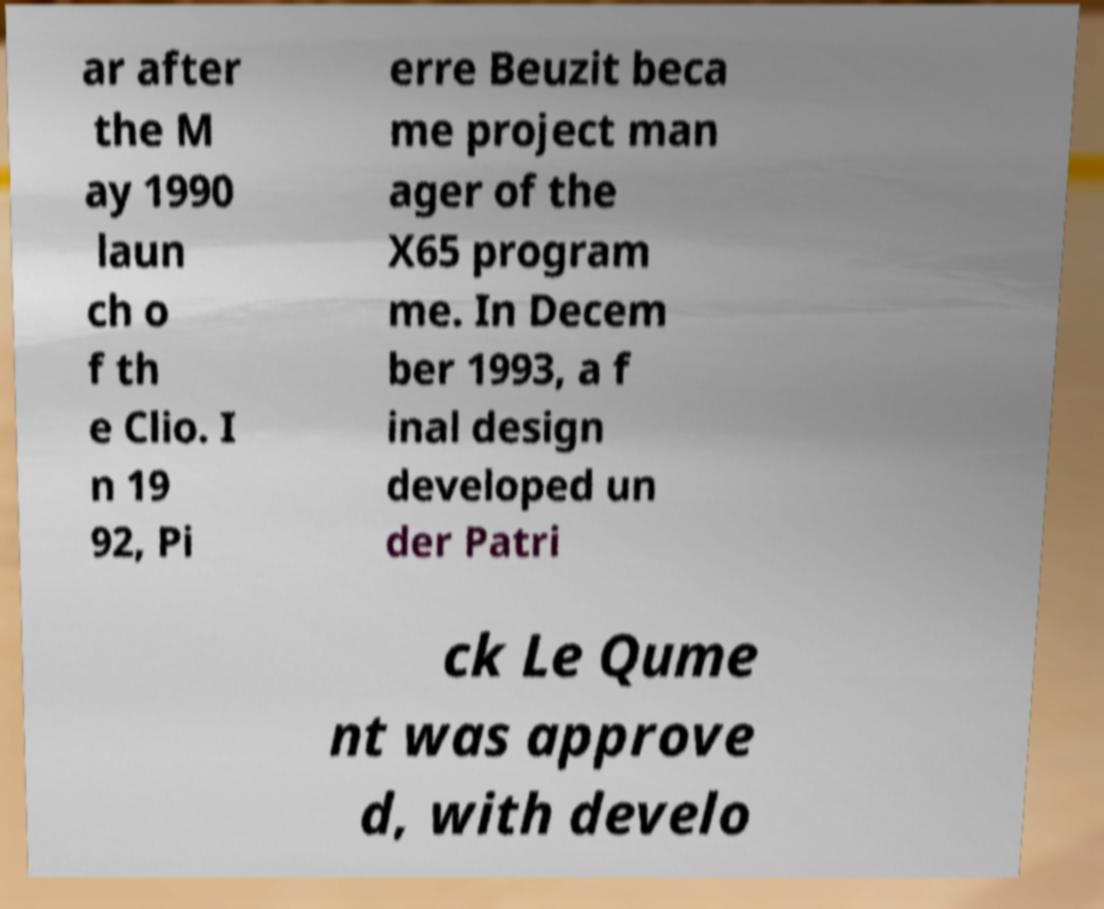Please read and relay the text visible in this image. What does it say? ar after the M ay 1990 laun ch o f th e Clio. I n 19 92, Pi erre Beuzit beca me project man ager of the X65 program me. In Decem ber 1993, a f inal design developed un der Patri ck Le Qume nt was approve d, with develo 